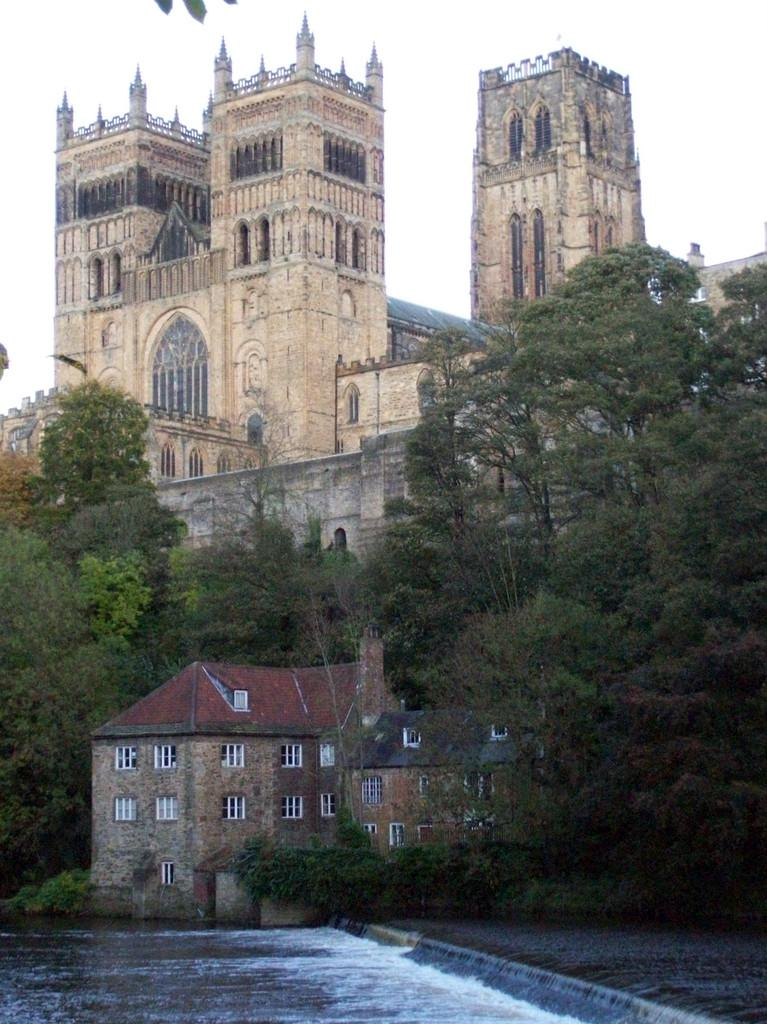What is the main subject of the image? The main subject of the image is Durham Cathedral. What can be seen in front of the cathedral? There are buildings and trees in front of the cathedral. Is there any water visible in the image? Yes, there is water in front of the cathedral. What is visible at the top of the image? The sky is visible at the top of the image. What type of drink is being served on the grass in the image? There is no drink or grass present in the image; it features Durham Cathedral with buildings, trees, water, and the sky. 